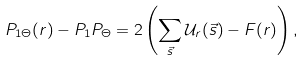<formula> <loc_0><loc_0><loc_500><loc_500>P _ { 1 \Theta } ( r ) - P _ { 1 } P _ { \Theta } = 2 \left ( \sum _ { \vec { s } } \mathcal { U } _ { r } ( \vec { s } ) - F ( r ) \right ) ,</formula> 